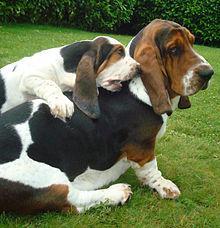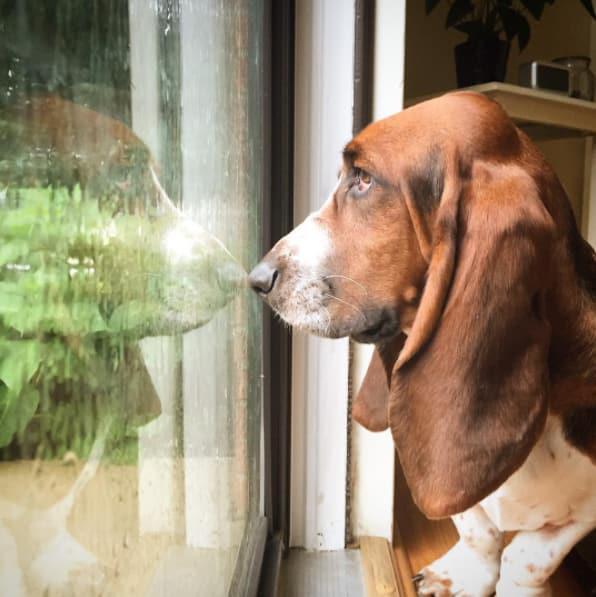The first image is the image on the left, the second image is the image on the right. Examine the images to the left and right. Is the description "bassett hounds are facing the camera" accurate? Answer yes or no. No. 